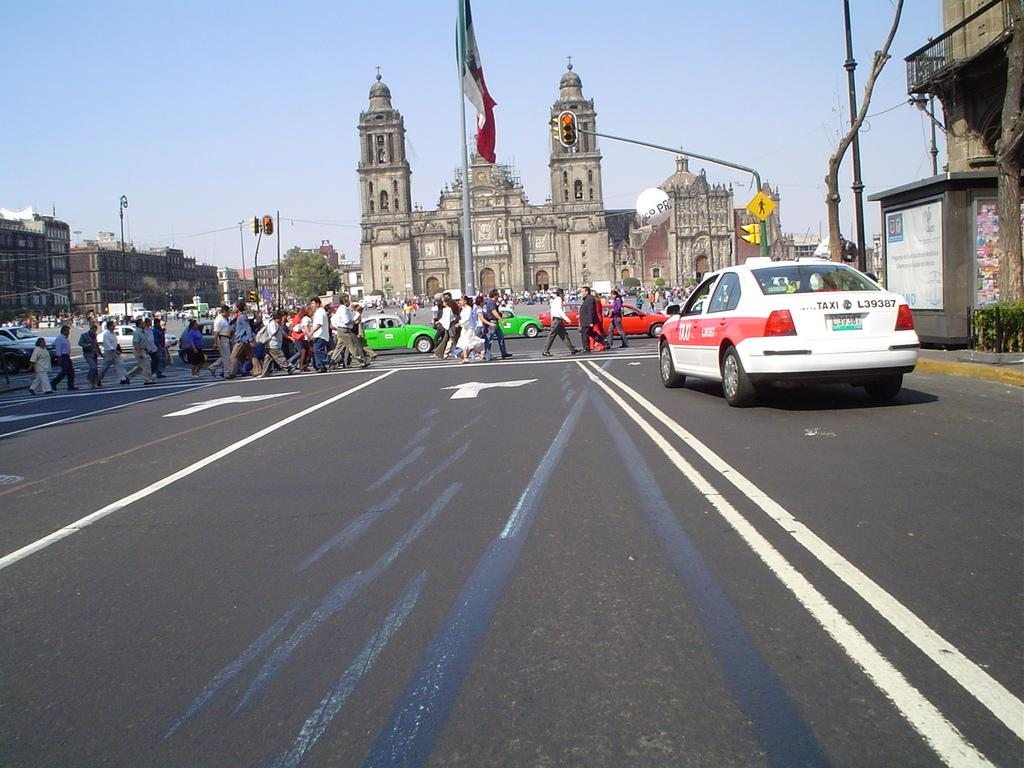<image>
Relay a brief, clear account of the picture shown. A white taxi is stopped at a red light, crowds of people are in the crosswalk. 